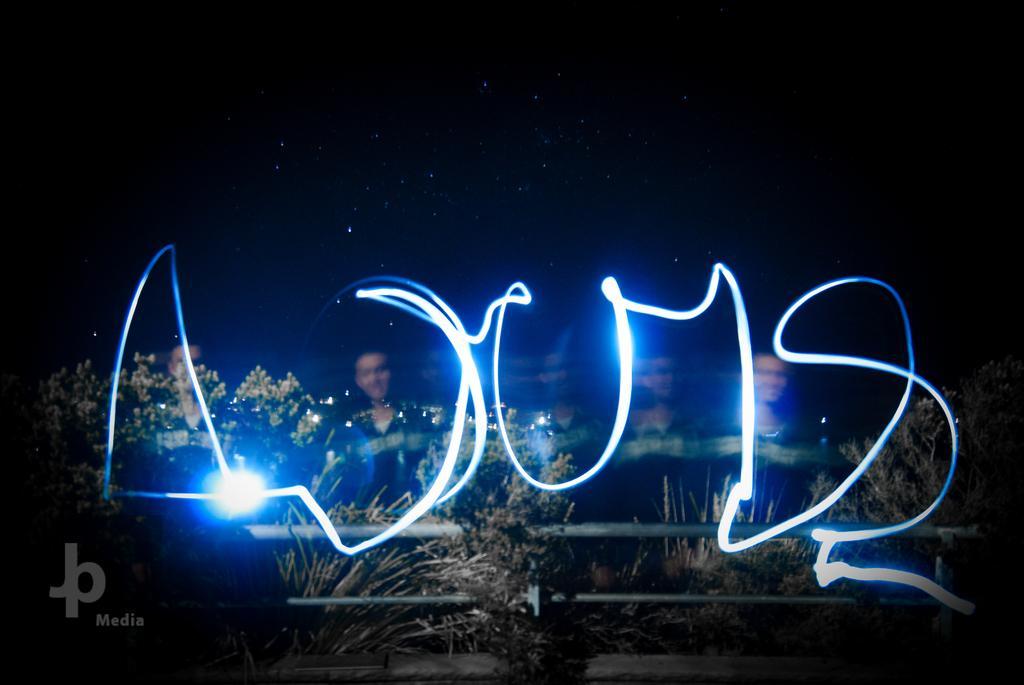Please provide a concise description of this image. In the image we can see there are people wearing clothes, this is a light, watermark, plant, pole, sky and we can even see the stars in the sky. 